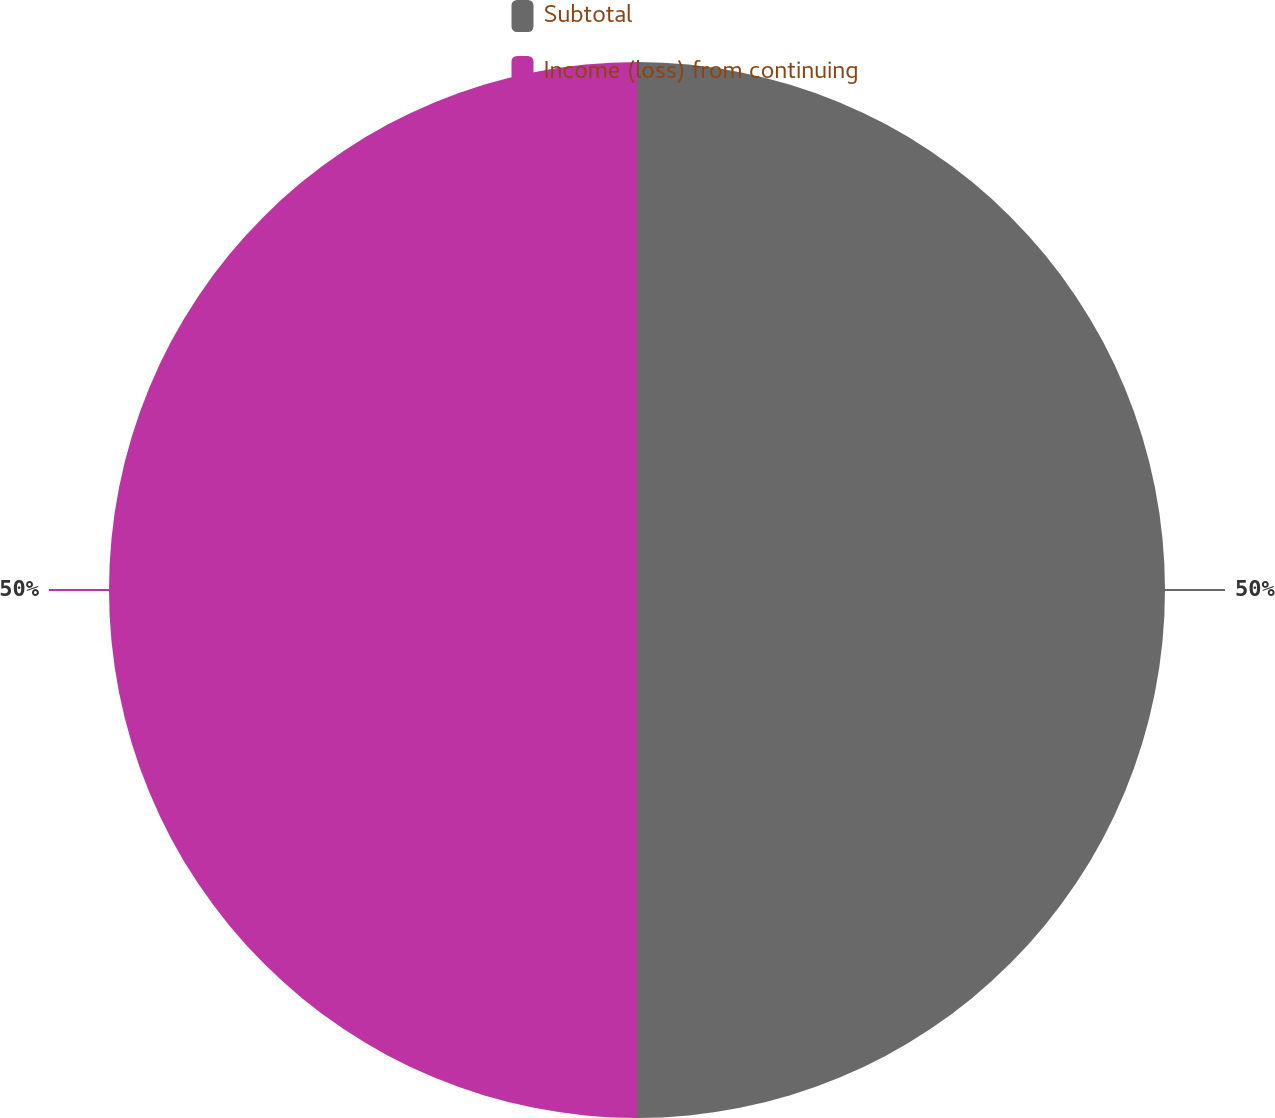Convert chart. <chart><loc_0><loc_0><loc_500><loc_500><pie_chart><fcel>Subtotal<fcel>Income (loss) from continuing<nl><fcel>50.0%<fcel>50.0%<nl></chart> 